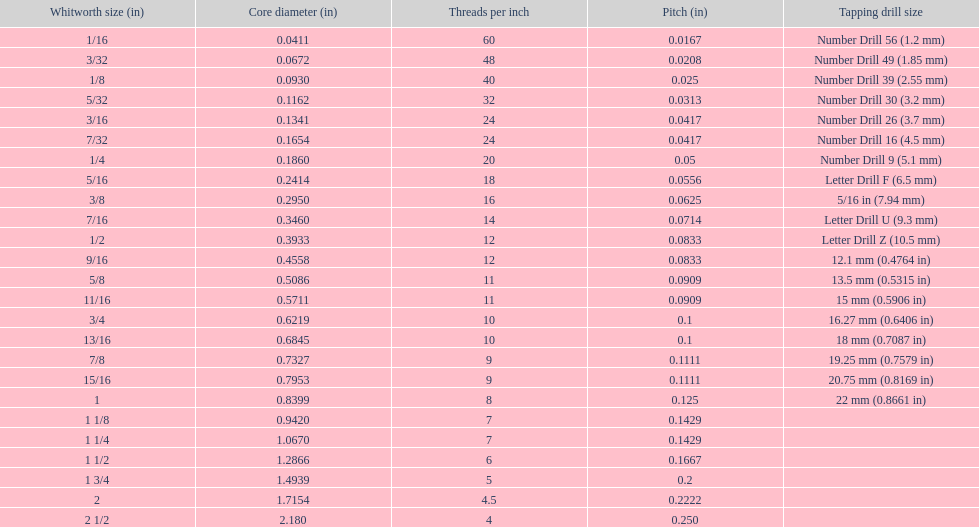What is the primary diameter of the last whitworth thread dimension? 2.180. 